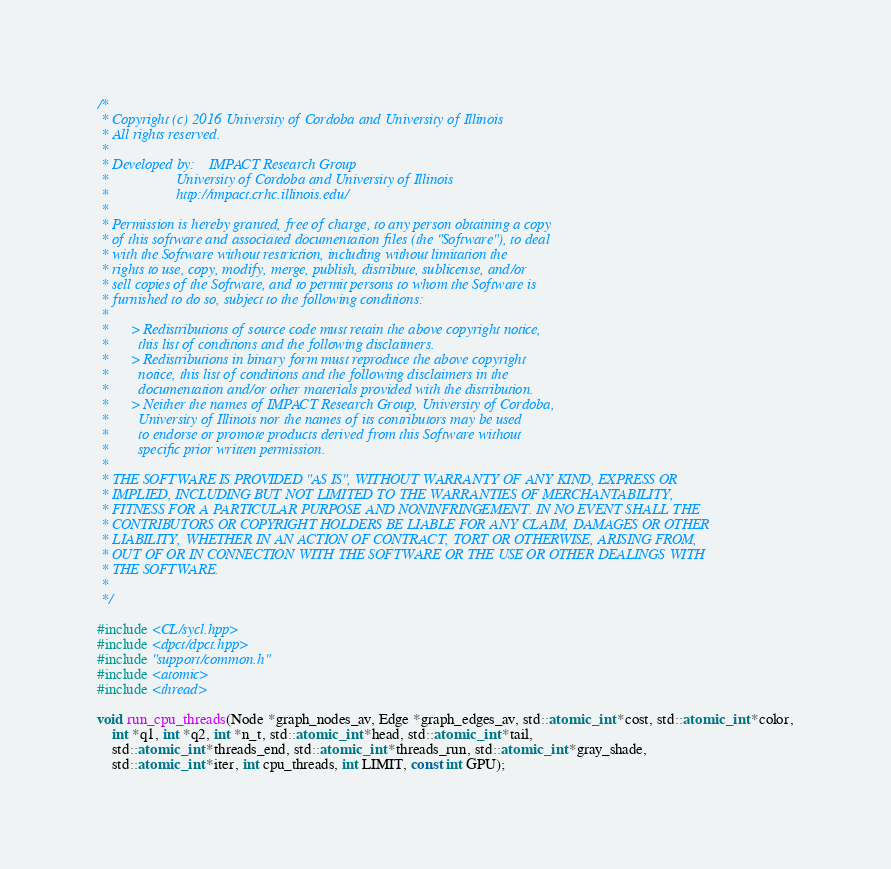<code> <loc_0><loc_0><loc_500><loc_500><_C_>/*
 * Copyright (c) 2016 University of Cordoba and University of Illinois
 * All rights reserved.
 *
 * Developed by:    IMPACT Research Group
 *                  University of Cordoba and University of Illinois
 *                  http://impact.crhc.illinois.edu/
 *
 * Permission is hereby granted, free of charge, to any person obtaining a copy
 * of this software and associated documentation files (the "Software"), to deal
 * with the Software without restriction, including without limitation the 
 * rights to use, copy, modify, merge, publish, distribute, sublicense, and/or
 * sell copies of the Software, and to permit persons to whom the Software is
 * furnished to do so, subject to the following conditions:
 *
 *      > Redistributions of source code must retain the above copyright notice,
 *        this list of conditions and the following disclaimers.
 *      > Redistributions in binary form must reproduce the above copyright
 *        notice, this list of conditions and the following disclaimers in the
 *        documentation and/or other materials provided with the distribution.
 *      > Neither the names of IMPACT Research Group, University of Cordoba, 
 *        University of Illinois nor the names of its contributors may be used 
 *        to endorse or promote products derived from this Software without 
 *        specific prior written permission.
 *
 * THE SOFTWARE IS PROVIDED "AS IS", WITHOUT WARRANTY OF ANY KIND, EXPRESS OR
 * IMPLIED, INCLUDING BUT NOT LIMITED TO THE WARRANTIES OF MERCHANTABILITY,
 * FITNESS FOR A PARTICULAR PURPOSE AND NONINFRINGEMENT. IN NO EVENT SHALL THE 
 * CONTRIBUTORS OR COPYRIGHT HOLDERS BE LIABLE FOR ANY CLAIM, DAMAGES OR OTHER
 * LIABILITY, WHETHER IN AN ACTION OF CONTRACT, TORT OR OTHERWISE, ARISING FROM,
 * OUT OF OR IN CONNECTION WITH THE SOFTWARE OR THE USE OR OTHER DEALINGS WITH
 * THE SOFTWARE.
 *
 */

#include <CL/sycl.hpp>
#include <dpct/dpct.hpp>
#include "support/common.h"
#include <atomic>
#include <thread>

void run_cpu_threads(Node *graph_nodes_av, Edge *graph_edges_av, std::atomic_int *cost, std::atomic_int *color,
    int *q1, int *q2, int *n_t, std::atomic_int *head, std::atomic_int *tail,
    std::atomic_int *threads_end, std::atomic_int *threads_run, std::atomic_int *gray_shade,
    std::atomic_int *iter, int cpu_threads, int LIMIT, const int GPU);
</code> 